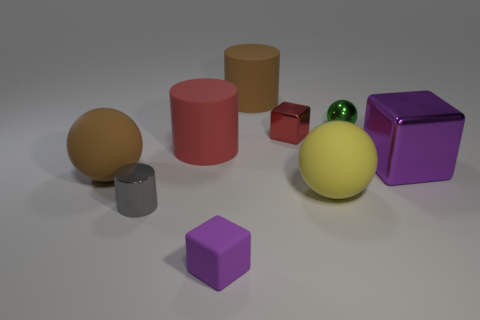How many yellow spheres have the same size as the green metal sphere?
Provide a short and direct response. 0. There is a rubber object that is the same color as the tiny metallic block; what is its size?
Offer a terse response. Large. The large rubber cylinder that is behind the large red matte object that is on the right side of the tiny shiny cylinder is what color?
Keep it short and to the point. Brown. Is there a large block that has the same color as the tiny rubber object?
Your response must be concise. Yes. There is a shiny sphere that is the same size as the gray cylinder; what color is it?
Your response must be concise. Green. Do the object that is in front of the small gray shiny thing and the tiny gray cylinder have the same material?
Keep it short and to the point. No. There is a purple thing to the left of the cylinder that is behind the metal ball; is there a tiny matte cube to the left of it?
Your answer should be compact. No. Is the shape of the large brown thing that is right of the tiny gray metallic cylinder the same as  the tiny gray thing?
Your answer should be compact. Yes. What shape is the tiny thing that is left of the matte cylinder in front of the red metallic block?
Your response must be concise. Cylinder. What is the size of the rubber sphere right of the large brown matte object that is in front of the metal block behind the large purple object?
Offer a terse response. Large. 